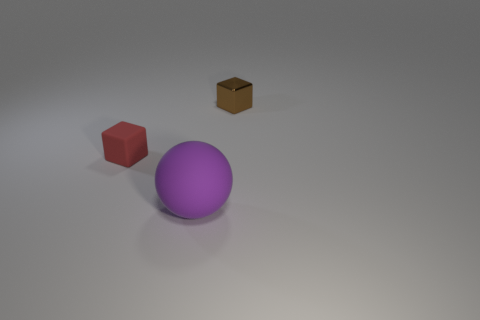Add 2 shiny blocks. How many objects exist? 5 Subtract all spheres. How many objects are left? 2 Subtract all small rubber objects. Subtract all small red spheres. How many objects are left? 2 Add 1 red things. How many red things are left? 2 Add 1 small blocks. How many small blocks exist? 3 Subtract 0 red cylinders. How many objects are left? 3 